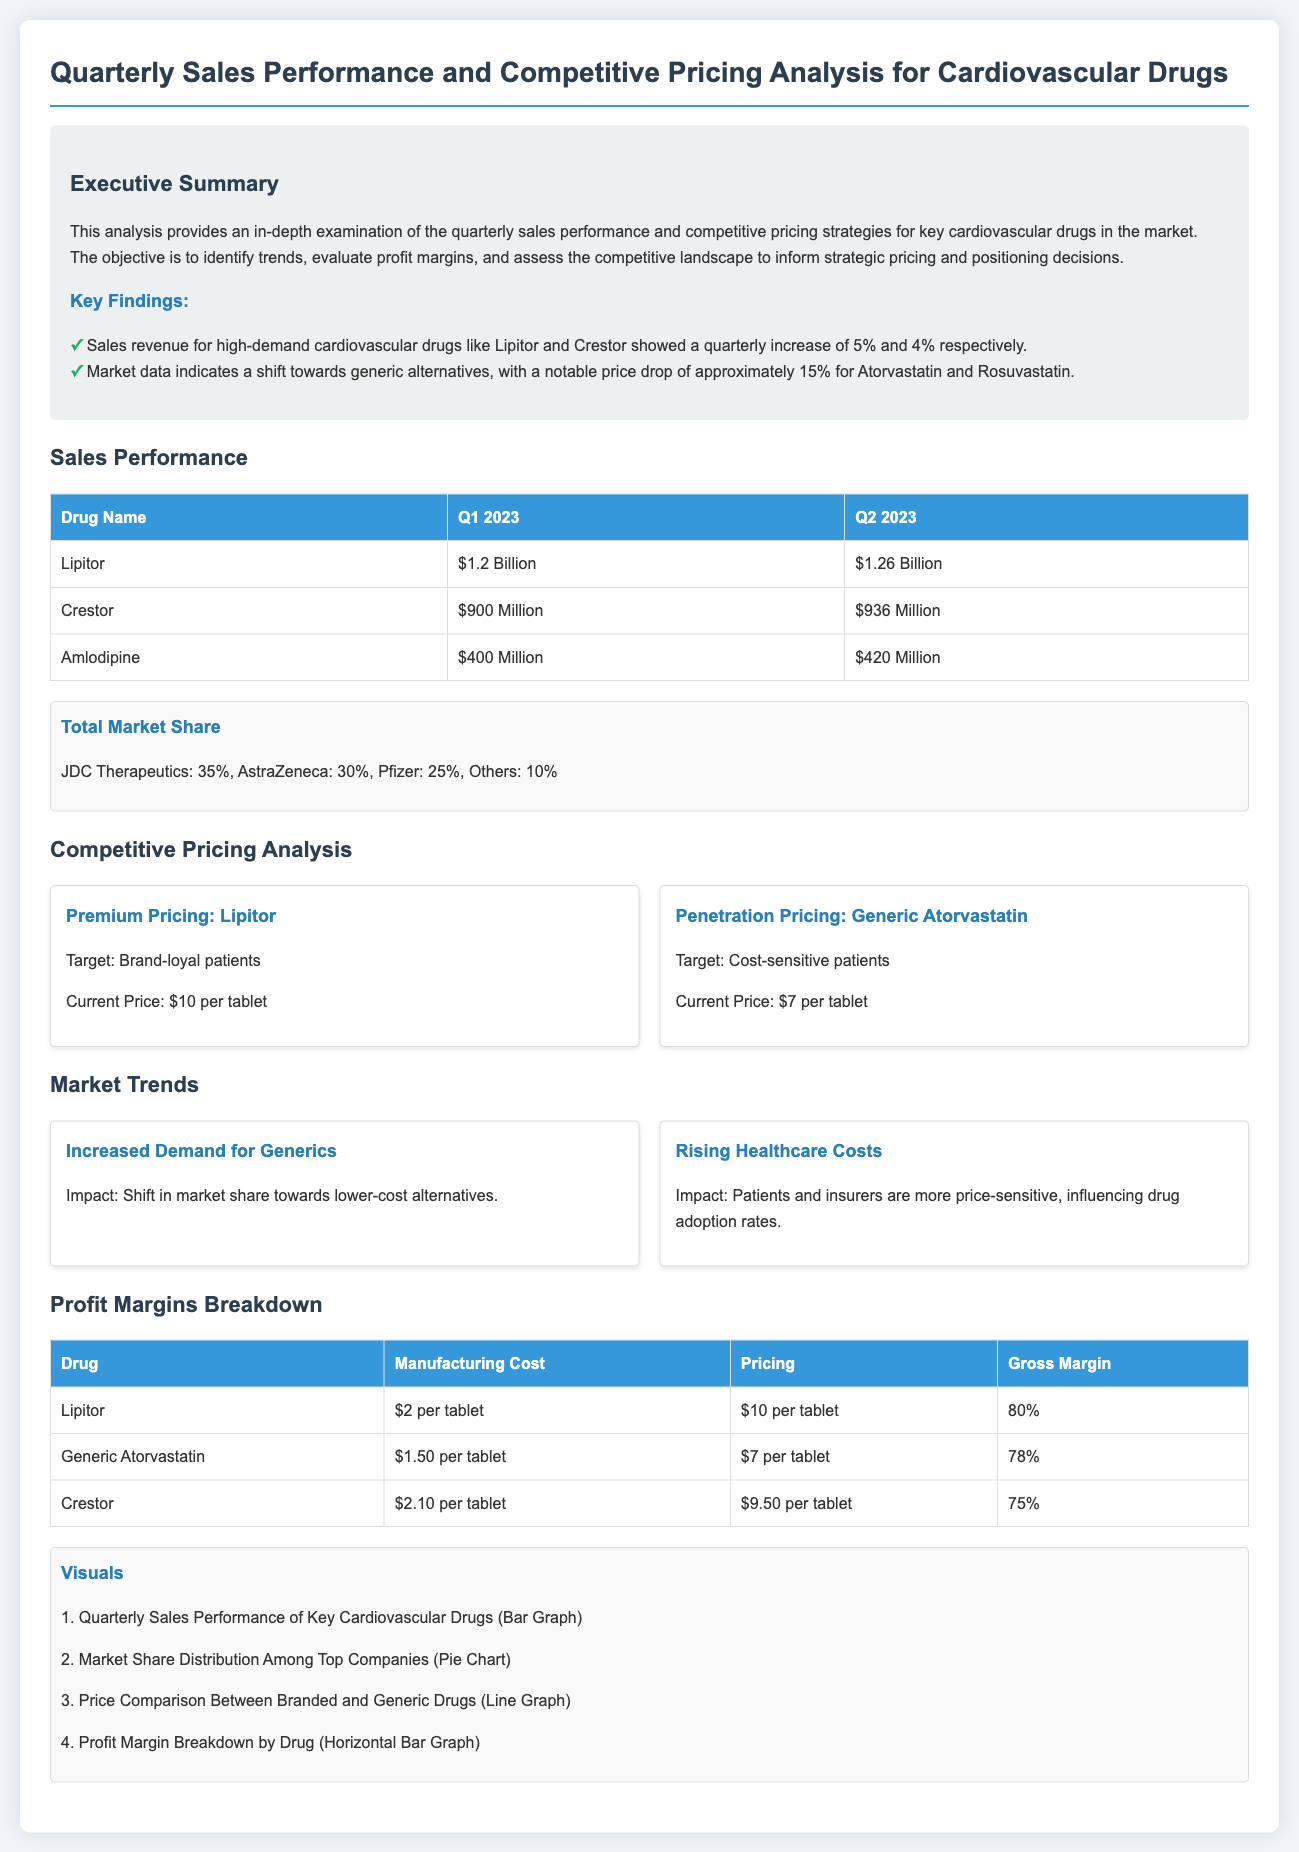What was the quarterly increase in sales for Lipitor? The document states that Lipitor showed a quarterly increase of 5%.
Answer: 5% What is the current price of Lipitor per tablet? According to the competitive pricing analysis, the current price of Lipitor is $10 per tablet.
Answer: $10 What was the sales revenue for Crestor in Q2 2023? The sales revenue for Crestor in Q2 2023 is listed as $936 Million.
Answer: $936 Million What is the gross margin for Generic Atorvastatin? The profit margins breakdown shows that the gross margin for Generic Atorvastatin is 78%.
Answer: 78% What percentage of the total market is held by JDC Therapeutics? The total market share breakdown indicates that JDC Therapeutics holds 35%.
Answer: 35% Which drug showed the highest gross margin? The profit margins breakdown indicates that Lipitor has the highest gross margin at 80%.
Answer: Lipitor What is the target market for Generic Atorvastatin? The document states that the target market for Generic Atorvastatin is cost-sensitive patients.
Answer: Cost-sensitive patients What impact do rising healthcare costs have according to the market trends? The document states that rising healthcare costs increase price sensitivity among patients and insurers.
Answer: Increase price sensitivity 